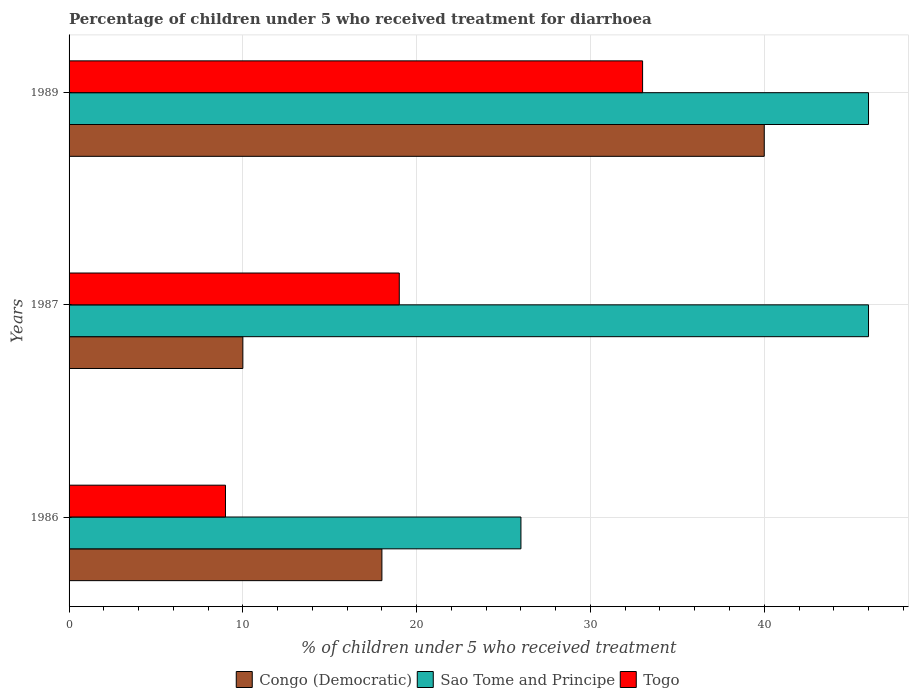How many different coloured bars are there?
Your response must be concise. 3. Are the number of bars on each tick of the Y-axis equal?
Make the answer very short. Yes. How many bars are there on the 2nd tick from the top?
Your answer should be compact. 3. Across all years, what is the maximum percentage of children who received treatment for diarrhoea  in Togo?
Keep it short and to the point. 33. In which year was the percentage of children who received treatment for diarrhoea  in Sao Tome and Principe minimum?
Your answer should be very brief. 1986. What is the total percentage of children who received treatment for diarrhoea  in Togo in the graph?
Your answer should be very brief. 61. What is the difference between the percentage of children who received treatment for diarrhoea  in Sao Tome and Principe in 1987 and that in 1989?
Your response must be concise. 0. What is the average percentage of children who received treatment for diarrhoea  in Togo per year?
Offer a terse response. 20.33. In the year 1987, what is the difference between the percentage of children who received treatment for diarrhoea  in Congo (Democratic) and percentage of children who received treatment for diarrhoea  in Sao Tome and Principe?
Your answer should be very brief. -36. In how many years, is the percentage of children who received treatment for diarrhoea  in Togo greater than 20 %?
Your answer should be compact. 1. What is the ratio of the percentage of children who received treatment for diarrhoea  in Togo in 1987 to that in 1989?
Provide a short and direct response. 0.58. Is the percentage of children who received treatment for diarrhoea  in Togo in 1986 less than that in 1989?
Offer a terse response. Yes. What is the difference between the highest and the second highest percentage of children who received treatment for diarrhoea  in Togo?
Your answer should be very brief. 14. In how many years, is the percentage of children who received treatment for diarrhoea  in Congo (Democratic) greater than the average percentage of children who received treatment for diarrhoea  in Congo (Democratic) taken over all years?
Your response must be concise. 1. Is the sum of the percentage of children who received treatment for diarrhoea  in Sao Tome and Principe in 1986 and 1987 greater than the maximum percentage of children who received treatment for diarrhoea  in Congo (Democratic) across all years?
Ensure brevity in your answer.  Yes. What does the 1st bar from the top in 1986 represents?
Make the answer very short. Togo. What does the 3rd bar from the bottom in 1987 represents?
Your answer should be compact. Togo. Is it the case that in every year, the sum of the percentage of children who received treatment for diarrhoea  in Togo and percentage of children who received treatment for diarrhoea  in Sao Tome and Principe is greater than the percentage of children who received treatment for diarrhoea  in Congo (Democratic)?
Ensure brevity in your answer.  Yes. How many bars are there?
Give a very brief answer. 9. How many years are there in the graph?
Your answer should be very brief. 3. Does the graph contain grids?
Make the answer very short. Yes. How many legend labels are there?
Your answer should be compact. 3. How are the legend labels stacked?
Provide a succinct answer. Horizontal. What is the title of the graph?
Offer a very short reply. Percentage of children under 5 who received treatment for diarrhoea. What is the label or title of the X-axis?
Your answer should be compact. % of children under 5 who received treatment. What is the label or title of the Y-axis?
Your response must be concise. Years. What is the % of children under 5 who received treatment of Congo (Democratic) in 1986?
Provide a short and direct response. 18. What is the % of children under 5 who received treatment in Togo in 1986?
Ensure brevity in your answer.  9. What is the % of children under 5 who received treatment of Sao Tome and Principe in 1989?
Your response must be concise. 46. What is the % of children under 5 who received treatment of Togo in 1989?
Your answer should be compact. 33. Across all years, what is the maximum % of children under 5 who received treatment in Congo (Democratic)?
Offer a terse response. 40. Across all years, what is the maximum % of children under 5 who received treatment in Togo?
Keep it short and to the point. 33. Across all years, what is the minimum % of children under 5 who received treatment of Congo (Democratic)?
Provide a succinct answer. 10. Across all years, what is the minimum % of children under 5 who received treatment of Togo?
Offer a terse response. 9. What is the total % of children under 5 who received treatment of Congo (Democratic) in the graph?
Give a very brief answer. 68. What is the total % of children under 5 who received treatment in Sao Tome and Principe in the graph?
Your response must be concise. 118. What is the total % of children under 5 who received treatment in Togo in the graph?
Give a very brief answer. 61. What is the difference between the % of children under 5 who received treatment in Sao Tome and Principe in 1986 and that in 1987?
Your answer should be very brief. -20. What is the difference between the % of children under 5 who received treatment of Togo in 1986 and that in 1987?
Provide a short and direct response. -10. What is the difference between the % of children under 5 who received treatment in Congo (Democratic) in 1986 and that in 1989?
Provide a short and direct response. -22. What is the difference between the % of children under 5 who received treatment in Sao Tome and Principe in 1986 and that in 1989?
Offer a very short reply. -20. What is the difference between the % of children under 5 who received treatment in Togo in 1986 and that in 1989?
Your answer should be very brief. -24. What is the difference between the % of children under 5 who received treatment in Congo (Democratic) in 1987 and that in 1989?
Provide a short and direct response. -30. What is the difference between the % of children under 5 who received treatment of Togo in 1987 and that in 1989?
Your answer should be very brief. -14. What is the difference between the % of children under 5 who received treatment of Congo (Democratic) in 1986 and the % of children under 5 who received treatment of Sao Tome and Principe in 1987?
Your answer should be very brief. -28. What is the difference between the % of children under 5 who received treatment of Congo (Democratic) in 1986 and the % of children under 5 who received treatment of Togo in 1987?
Offer a terse response. -1. What is the difference between the % of children under 5 who received treatment in Congo (Democratic) in 1986 and the % of children under 5 who received treatment in Sao Tome and Principe in 1989?
Your answer should be compact. -28. What is the difference between the % of children under 5 who received treatment of Sao Tome and Principe in 1986 and the % of children under 5 who received treatment of Togo in 1989?
Ensure brevity in your answer.  -7. What is the difference between the % of children under 5 who received treatment in Congo (Democratic) in 1987 and the % of children under 5 who received treatment in Sao Tome and Principe in 1989?
Offer a terse response. -36. What is the difference between the % of children under 5 who received treatment of Congo (Democratic) in 1987 and the % of children under 5 who received treatment of Togo in 1989?
Keep it short and to the point. -23. What is the difference between the % of children under 5 who received treatment of Sao Tome and Principe in 1987 and the % of children under 5 who received treatment of Togo in 1989?
Provide a succinct answer. 13. What is the average % of children under 5 who received treatment in Congo (Democratic) per year?
Make the answer very short. 22.67. What is the average % of children under 5 who received treatment of Sao Tome and Principe per year?
Provide a short and direct response. 39.33. What is the average % of children under 5 who received treatment in Togo per year?
Offer a very short reply. 20.33. In the year 1986, what is the difference between the % of children under 5 who received treatment of Congo (Democratic) and % of children under 5 who received treatment of Togo?
Make the answer very short. 9. In the year 1986, what is the difference between the % of children under 5 who received treatment in Sao Tome and Principe and % of children under 5 who received treatment in Togo?
Provide a succinct answer. 17. In the year 1987, what is the difference between the % of children under 5 who received treatment of Congo (Democratic) and % of children under 5 who received treatment of Sao Tome and Principe?
Your answer should be very brief. -36. In the year 1987, what is the difference between the % of children under 5 who received treatment in Congo (Democratic) and % of children under 5 who received treatment in Togo?
Provide a succinct answer. -9. What is the ratio of the % of children under 5 who received treatment in Sao Tome and Principe in 1986 to that in 1987?
Offer a terse response. 0.57. What is the ratio of the % of children under 5 who received treatment of Togo in 1986 to that in 1987?
Your answer should be very brief. 0.47. What is the ratio of the % of children under 5 who received treatment of Congo (Democratic) in 1986 to that in 1989?
Offer a terse response. 0.45. What is the ratio of the % of children under 5 who received treatment of Sao Tome and Principe in 1986 to that in 1989?
Provide a succinct answer. 0.57. What is the ratio of the % of children under 5 who received treatment in Togo in 1986 to that in 1989?
Give a very brief answer. 0.27. What is the ratio of the % of children under 5 who received treatment of Sao Tome and Principe in 1987 to that in 1989?
Your answer should be very brief. 1. What is the ratio of the % of children under 5 who received treatment of Togo in 1987 to that in 1989?
Your answer should be very brief. 0.58. What is the difference between the highest and the lowest % of children under 5 who received treatment in Sao Tome and Principe?
Offer a very short reply. 20. 